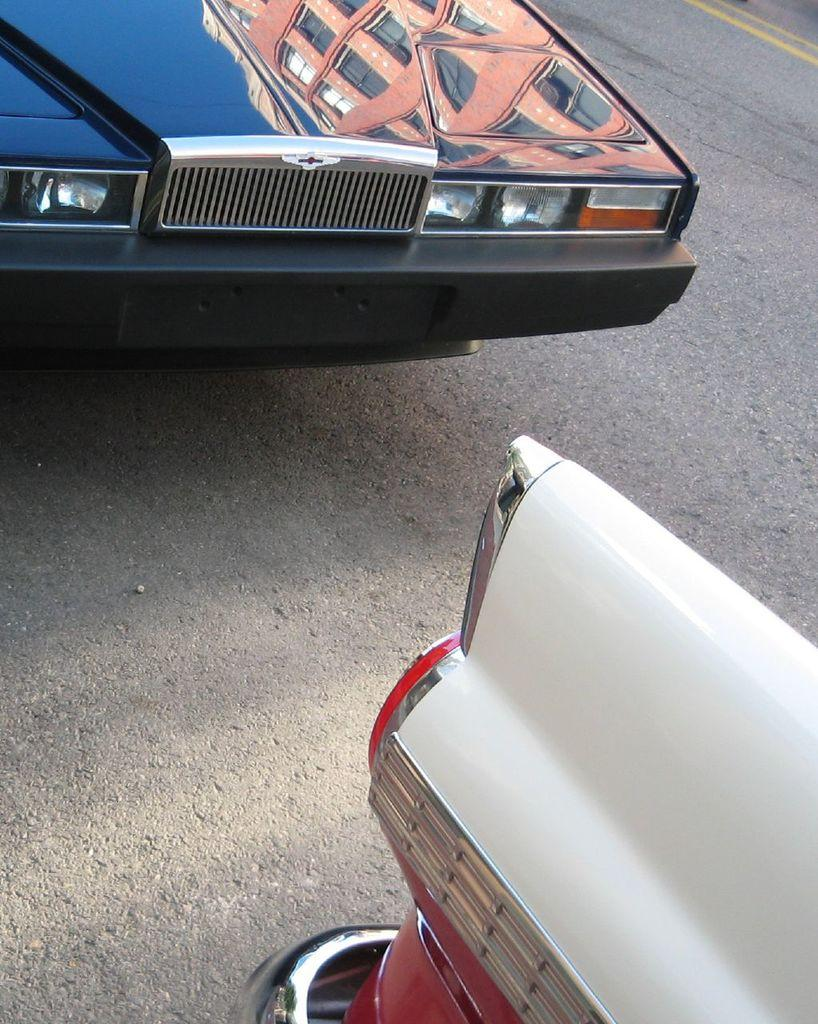What type of vehicles can be seen on the road in the image? There are motor vehicles on the road in the image. How does the butter affect the performance of the motor vehicles in the image? There is no butter present in the image, so its effect on the performance of the motor vehicles cannot be determined. 